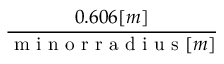Convert formula to latex. <formula><loc_0><loc_0><loc_500><loc_500>\frac { 0 . 6 0 6 [ m ] } { m i n o r r a d i u s [ m ] }</formula> 